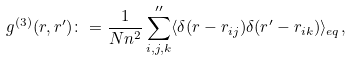Convert formula to latex. <formula><loc_0><loc_0><loc_500><loc_500>g ^ { ( 3 ) } ( r , r ^ { \prime } ) \colon = \frac { 1 } { N n ^ { 2 } } \sum _ { i , j , k } ^ { \prime \prime } \langle \delta ( r - r _ { i j } ) \delta ( r ^ { \prime } - r _ { i k } ) \rangle _ { e q } ,</formula> 